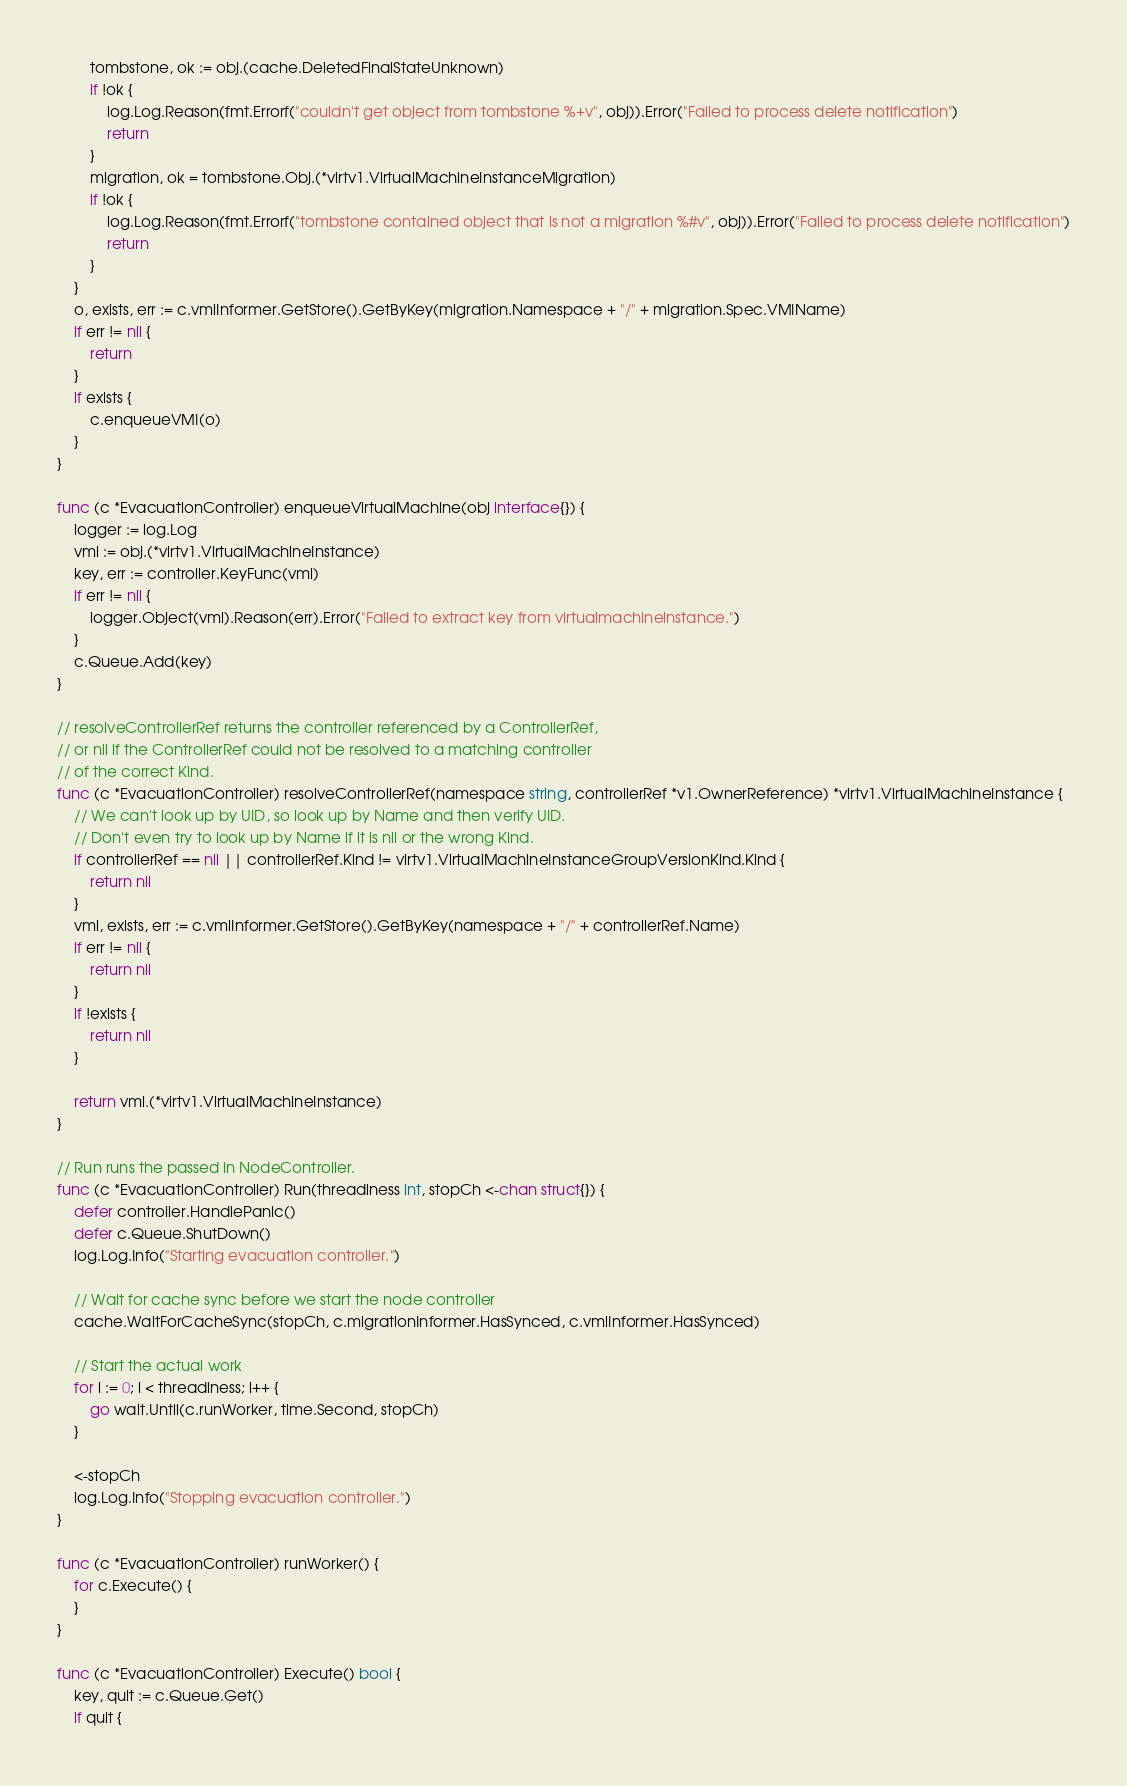<code> <loc_0><loc_0><loc_500><loc_500><_Go_>		tombstone, ok := obj.(cache.DeletedFinalStateUnknown)
		if !ok {
			log.Log.Reason(fmt.Errorf("couldn't get object from tombstone %+v", obj)).Error("Failed to process delete notification")
			return
		}
		migration, ok = tombstone.Obj.(*virtv1.VirtualMachineInstanceMigration)
		if !ok {
			log.Log.Reason(fmt.Errorf("tombstone contained object that is not a migration %#v", obj)).Error("Failed to process delete notification")
			return
		}
	}
	o, exists, err := c.vmiInformer.GetStore().GetByKey(migration.Namespace + "/" + migration.Spec.VMIName)
	if err != nil {
		return
	}
	if exists {
		c.enqueueVMI(o)
	}
}

func (c *EvacuationController) enqueueVirtualMachine(obj interface{}) {
	logger := log.Log
	vmi := obj.(*virtv1.VirtualMachineInstance)
	key, err := controller.KeyFunc(vmi)
	if err != nil {
		logger.Object(vmi).Reason(err).Error("Failed to extract key from virtualmachineinstance.")
	}
	c.Queue.Add(key)
}

// resolveControllerRef returns the controller referenced by a ControllerRef,
// or nil if the ControllerRef could not be resolved to a matching controller
// of the correct Kind.
func (c *EvacuationController) resolveControllerRef(namespace string, controllerRef *v1.OwnerReference) *virtv1.VirtualMachineInstance {
	// We can't look up by UID, so look up by Name and then verify UID.
	// Don't even try to look up by Name if it is nil or the wrong Kind.
	if controllerRef == nil || controllerRef.Kind != virtv1.VirtualMachineInstanceGroupVersionKind.Kind {
		return nil
	}
	vmi, exists, err := c.vmiInformer.GetStore().GetByKey(namespace + "/" + controllerRef.Name)
	if err != nil {
		return nil
	}
	if !exists {
		return nil
	}

	return vmi.(*virtv1.VirtualMachineInstance)
}

// Run runs the passed in NodeController.
func (c *EvacuationController) Run(threadiness int, stopCh <-chan struct{}) {
	defer controller.HandlePanic()
	defer c.Queue.ShutDown()
	log.Log.Info("Starting evacuation controller.")

	// Wait for cache sync before we start the node controller
	cache.WaitForCacheSync(stopCh, c.migrationInformer.HasSynced, c.vmiInformer.HasSynced)

	// Start the actual work
	for i := 0; i < threadiness; i++ {
		go wait.Until(c.runWorker, time.Second, stopCh)
	}

	<-stopCh
	log.Log.Info("Stopping evacuation controller.")
}

func (c *EvacuationController) runWorker() {
	for c.Execute() {
	}
}

func (c *EvacuationController) Execute() bool {
	key, quit := c.Queue.Get()
	if quit {</code> 